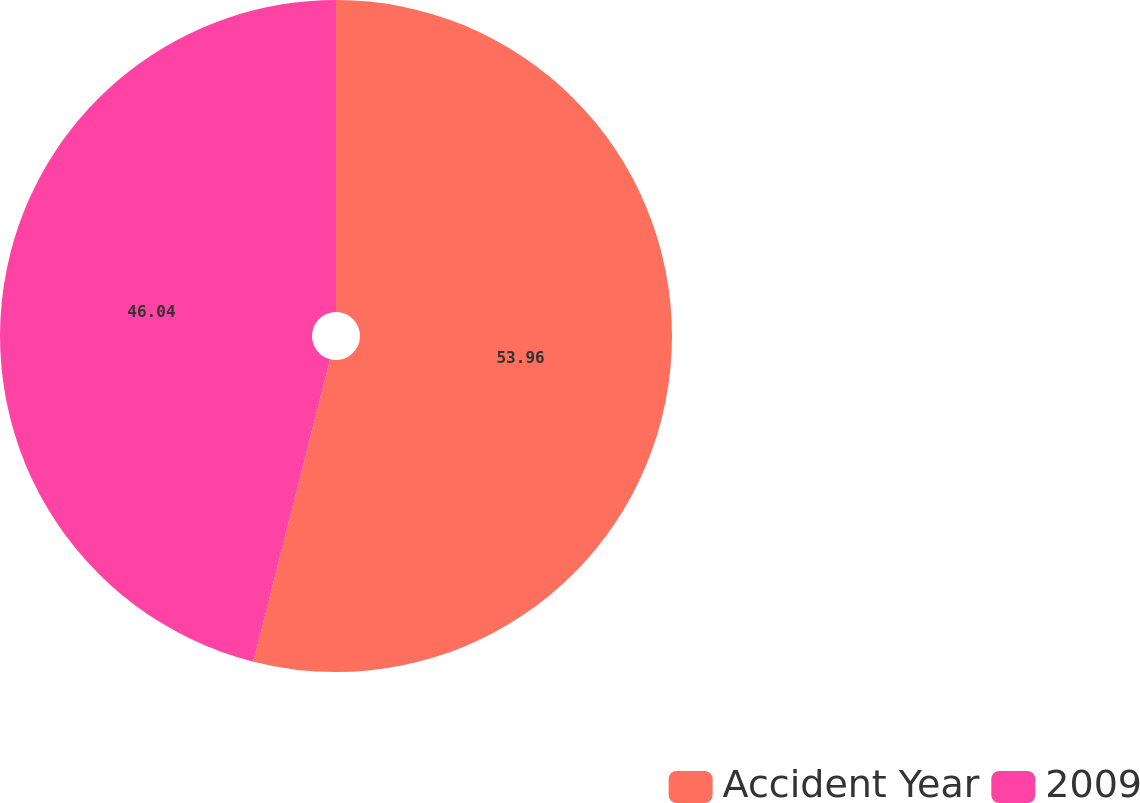<chart> <loc_0><loc_0><loc_500><loc_500><pie_chart><fcel>Accident Year<fcel>2009<nl><fcel>53.96%<fcel>46.04%<nl></chart> 